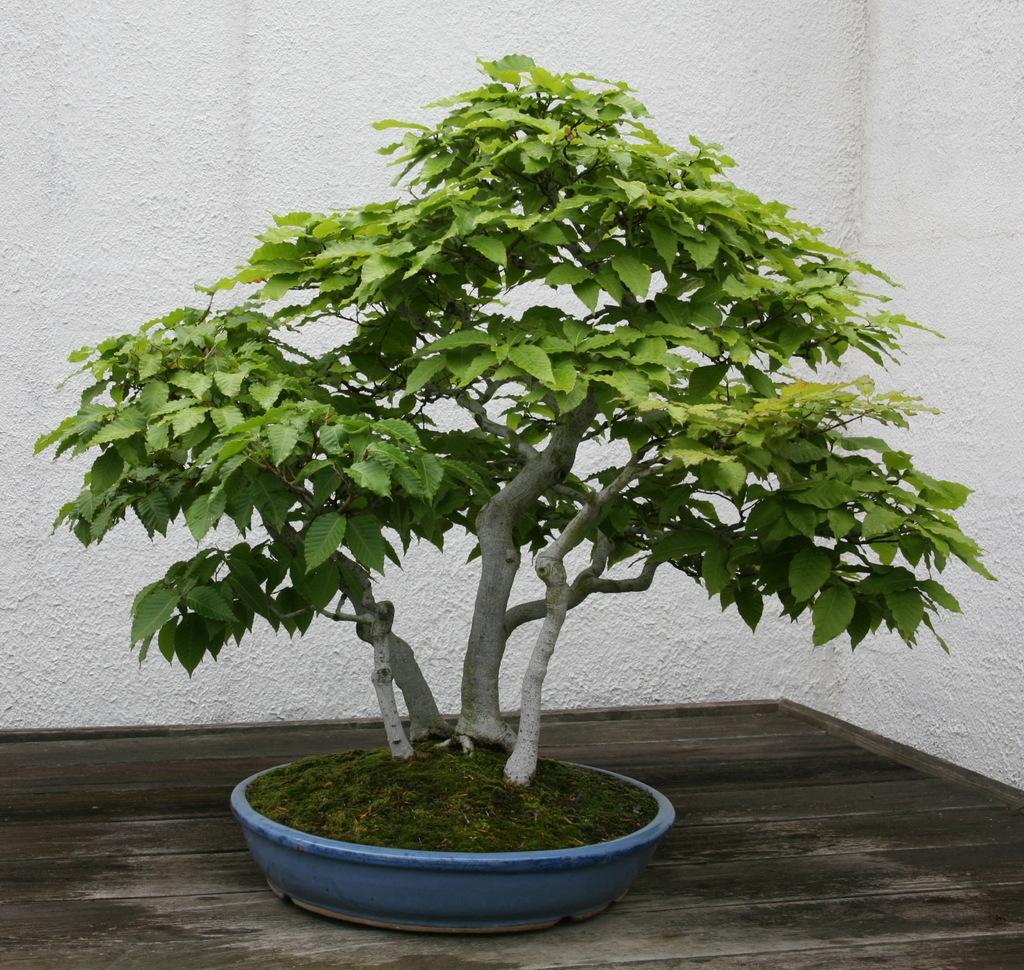In one or two sentences, can you explain what this image depicts? In this image we can see a plant in a pot which is placed on a wooden surface. Behind the plant there is a wall. 